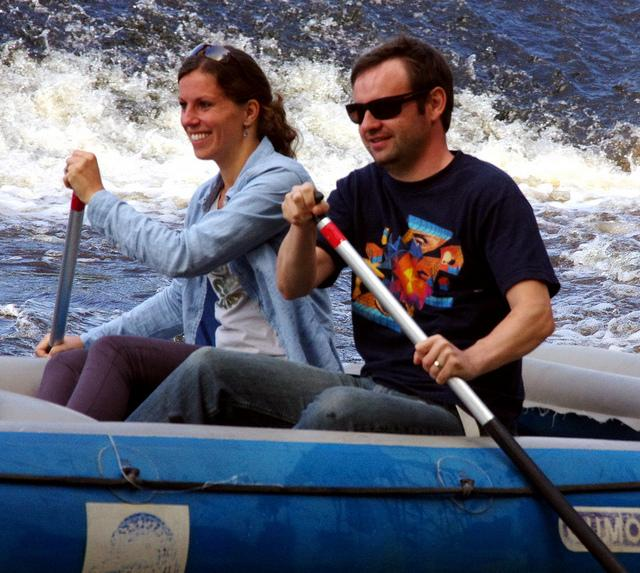What should they have worn before starting the activity?

Choices:
A) life jacket
B) headband
C) wristband
D) helmet life jacket 